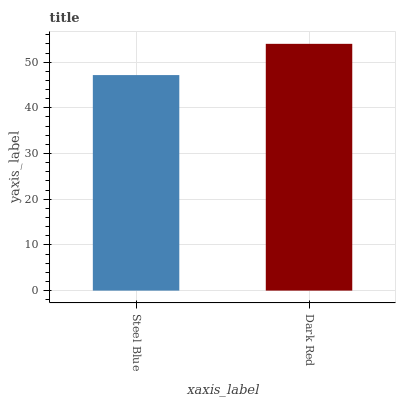Is Steel Blue the minimum?
Answer yes or no. Yes. Is Dark Red the maximum?
Answer yes or no. Yes. Is Dark Red the minimum?
Answer yes or no. No. Is Dark Red greater than Steel Blue?
Answer yes or no. Yes. Is Steel Blue less than Dark Red?
Answer yes or no. Yes. Is Steel Blue greater than Dark Red?
Answer yes or no. No. Is Dark Red less than Steel Blue?
Answer yes or no. No. Is Dark Red the high median?
Answer yes or no. Yes. Is Steel Blue the low median?
Answer yes or no. Yes. Is Steel Blue the high median?
Answer yes or no. No. Is Dark Red the low median?
Answer yes or no. No. 